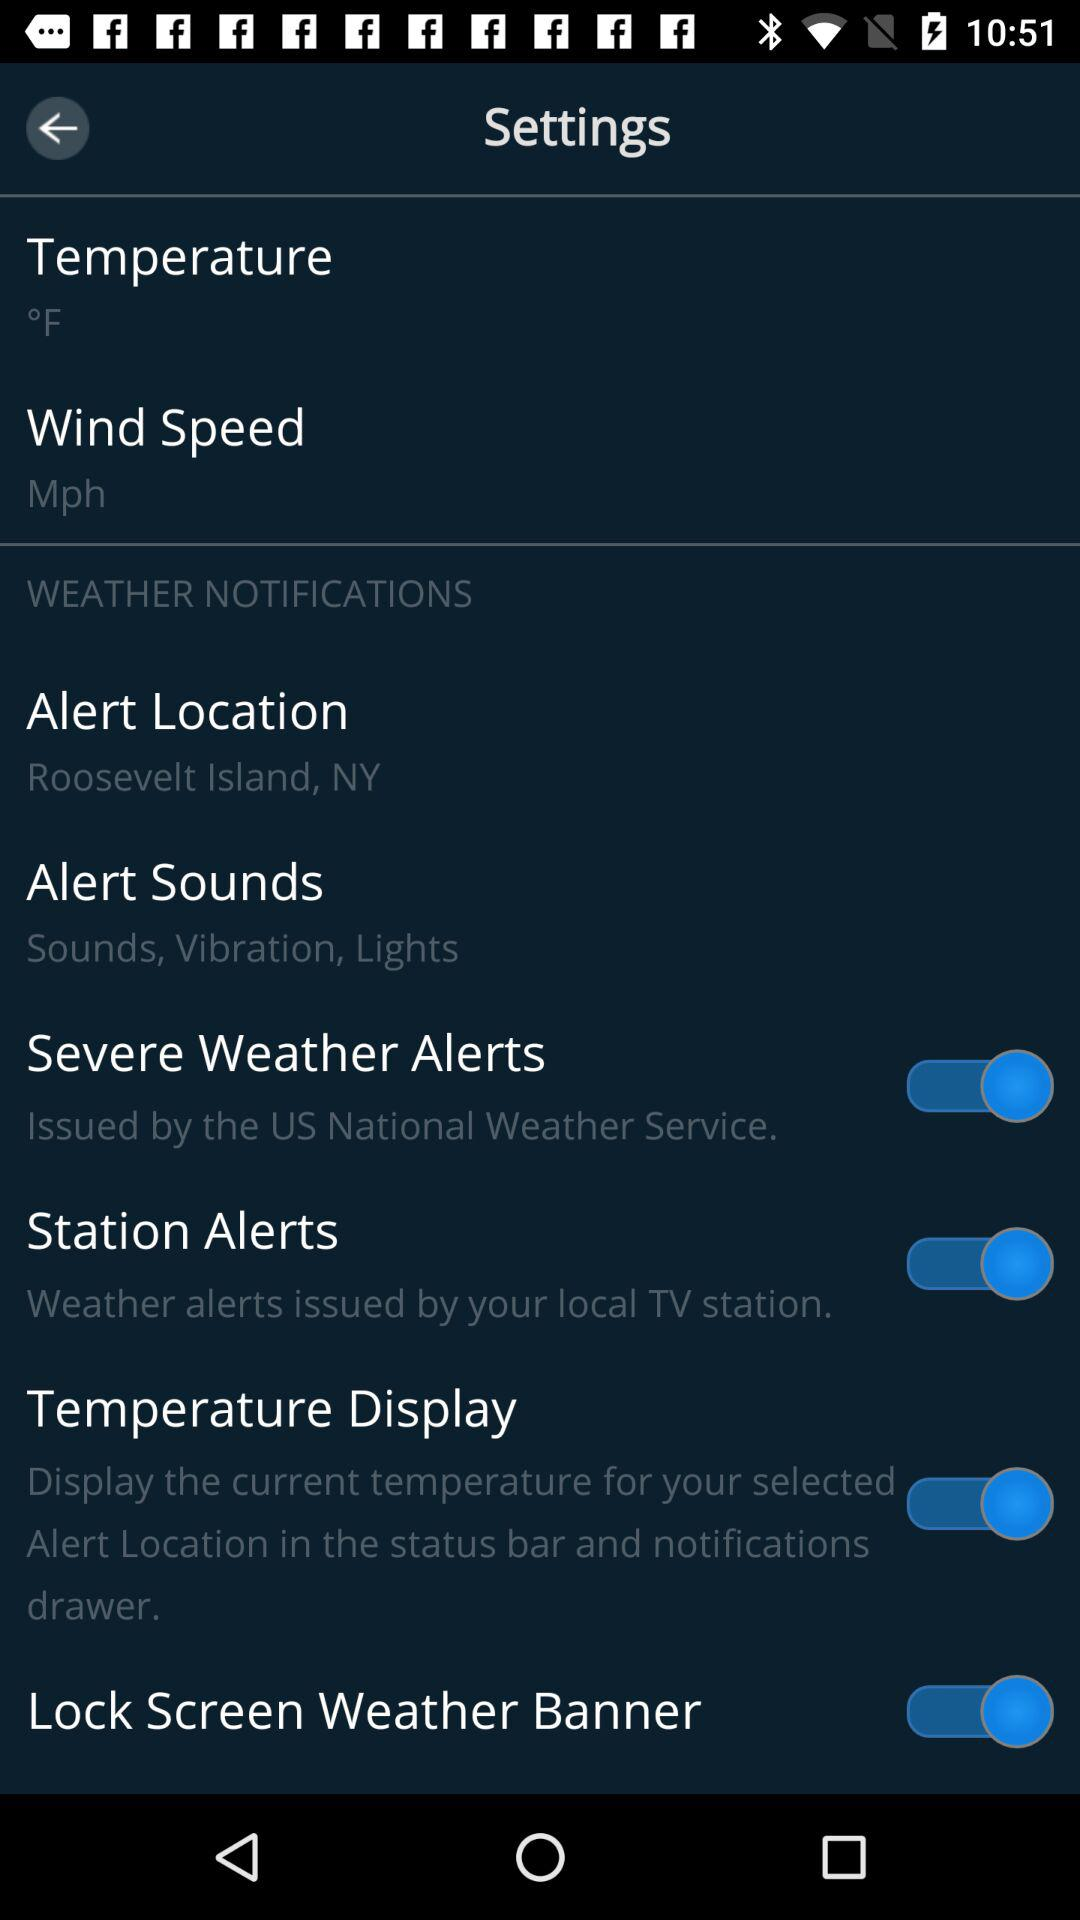How many more alert options are there that are not issued by the US National Weather Service?
Answer the question using a single word or phrase. 1 